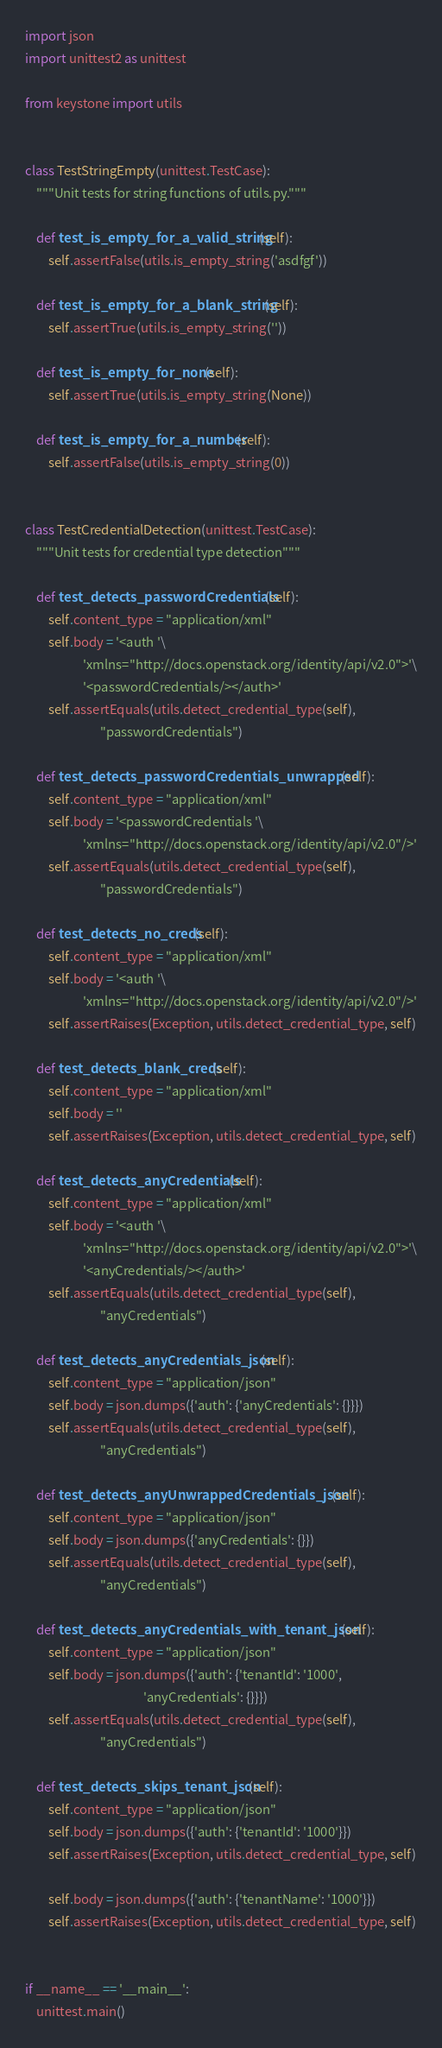<code> <loc_0><loc_0><loc_500><loc_500><_Python_>import json
import unittest2 as unittest

from keystone import utils


class TestStringEmpty(unittest.TestCase):
    """Unit tests for string functions of utils.py."""

    def test_is_empty_for_a_valid_string(self):
        self.assertFalse(utils.is_empty_string('asdfgf'))

    def test_is_empty_for_a_blank_string(self):
        self.assertTrue(utils.is_empty_string(''))

    def test_is_empty_for_none(self):
        self.assertTrue(utils.is_empty_string(None))

    def test_is_empty_for_a_number(self):
        self.assertFalse(utils.is_empty_string(0))


class TestCredentialDetection(unittest.TestCase):
    """Unit tests for credential type detection"""

    def test_detects_passwordCredentials(self):
        self.content_type = "application/xml"
        self.body = '<auth '\
                    'xmlns="http://docs.openstack.org/identity/api/v2.0">'\
                    '<passwordCredentials/></auth>'
        self.assertEquals(utils.detect_credential_type(self),
                          "passwordCredentials")

    def test_detects_passwordCredentials_unwrapped(self):
        self.content_type = "application/xml"
        self.body = '<passwordCredentials '\
                    'xmlns="http://docs.openstack.org/identity/api/v2.0"/>'
        self.assertEquals(utils.detect_credential_type(self),
                          "passwordCredentials")

    def test_detects_no_creds(self):
        self.content_type = "application/xml"
        self.body = '<auth '\
                    'xmlns="http://docs.openstack.org/identity/api/v2.0"/>'
        self.assertRaises(Exception, utils.detect_credential_type, self)

    def test_detects_blank_creds(self):
        self.content_type = "application/xml"
        self.body = ''
        self.assertRaises(Exception, utils.detect_credential_type, self)

    def test_detects_anyCredentials(self):
        self.content_type = "application/xml"
        self.body = '<auth '\
                    'xmlns="http://docs.openstack.org/identity/api/v2.0">'\
                    '<anyCredentials/></auth>'
        self.assertEquals(utils.detect_credential_type(self),
                          "anyCredentials")

    def test_detects_anyCredentials_json(self):
        self.content_type = "application/json"
        self.body = json.dumps({'auth': {'anyCredentials': {}}})
        self.assertEquals(utils.detect_credential_type(self),
                          "anyCredentials")

    def test_detects_anyUnwrappedCredentials_json(self):
        self.content_type = "application/json"
        self.body = json.dumps({'anyCredentials': {}})
        self.assertEquals(utils.detect_credential_type(self),
                          "anyCredentials")

    def test_detects_anyCredentials_with_tenant_json(self):
        self.content_type = "application/json"
        self.body = json.dumps({'auth': {'tenantId': '1000',
                                         'anyCredentials': {}}})
        self.assertEquals(utils.detect_credential_type(self),
                          "anyCredentials")

    def test_detects_skips_tenant_json(self):
        self.content_type = "application/json"
        self.body = json.dumps({'auth': {'tenantId': '1000'}})
        self.assertRaises(Exception, utils.detect_credential_type, self)

        self.body = json.dumps({'auth': {'tenantName': '1000'}})
        self.assertRaises(Exception, utils.detect_credential_type, self)


if __name__ == '__main__':
    unittest.main()
</code> 